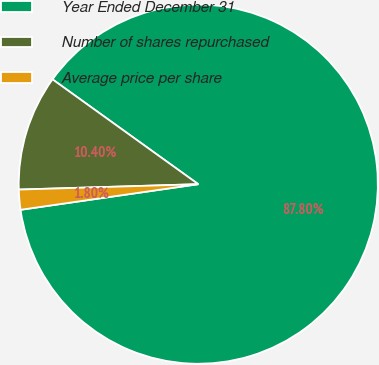Convert chart to OTSL. <chart><loc_0><loc_0><loc_500><loc_500><pie_chart><fcel>Year Ended December 31<fcel>Number of shares repurchased<fcel>Average price per share<nl><fcel>87.8%<fcel>10.4%<fcel>1.8%<nl></chart> 